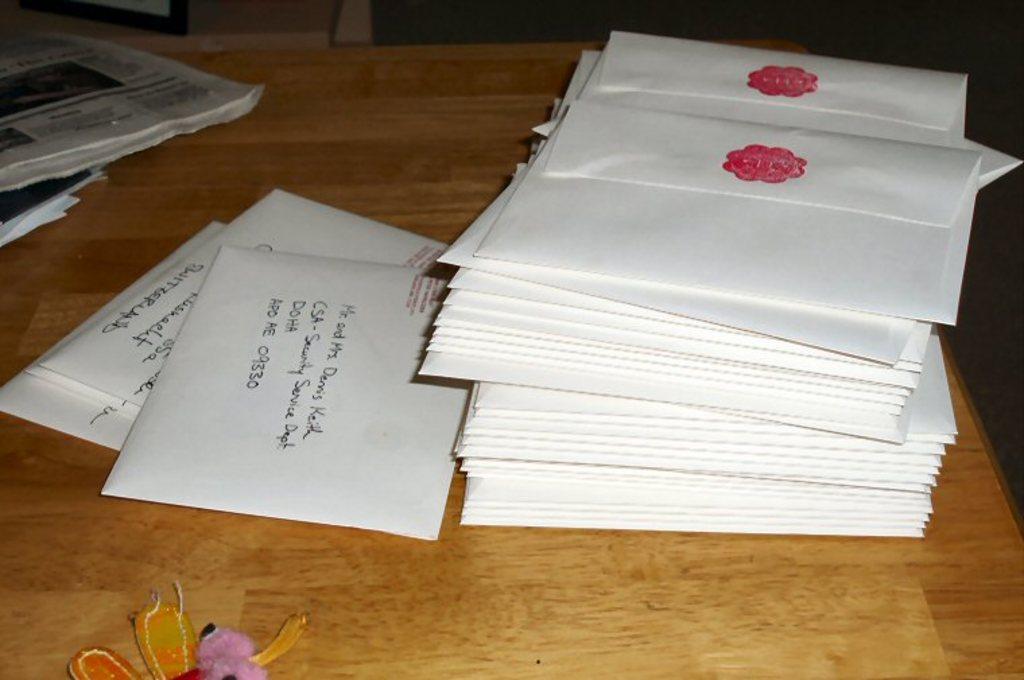What is the area code that the letter is being sent to?
Ensure brevity in your answer.  09330. 